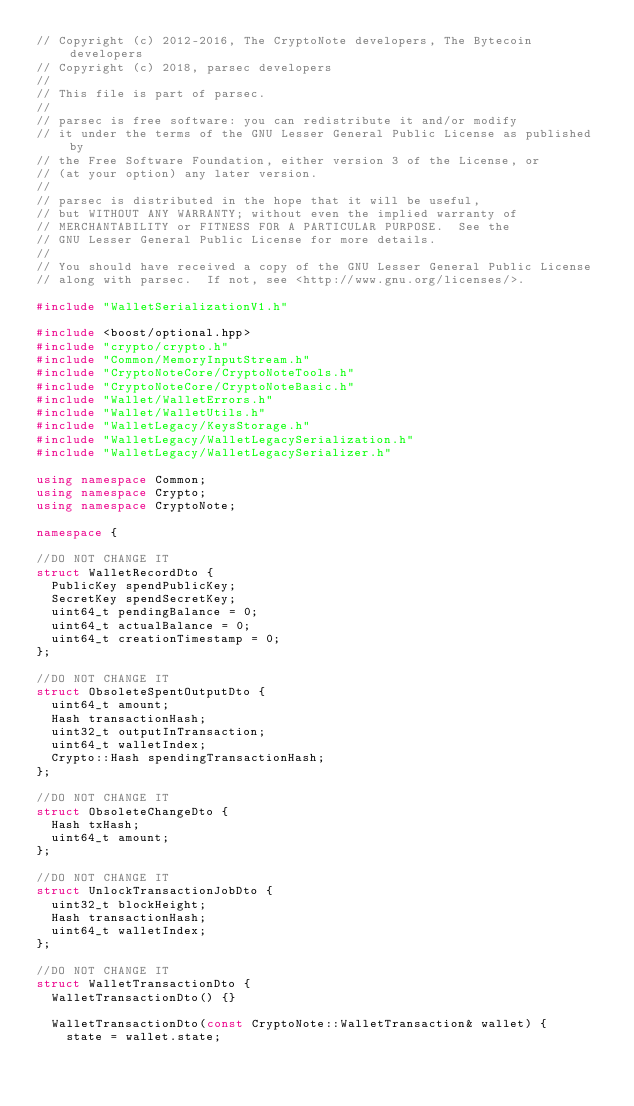Convert code to text. <code><loc_0><loc_0><loc_500><loc_500><_C++_>// Copyright (c) 2012-2016, The CryptoNote developers, The Bytecoin developers
// Copyright (c) 2018, parsec developers
//
// This file is part of parsec.
//
// parsec is free software: you can redistribute it and/or modify
// it under the terms of the GNU Lesser General Public License as published by
// the Free Software Foundation, either version 3 of the License, or
// (at your option) any later version.
//
// parsec is distributed in the hope that it will be useful,
// but WITHOUT ANY WARRANTY; without even the implied warranty of
// MERCHANTABILITY or FITNESS FOR A PARTICULAR PURPOSE.  See the
// GNU Lesser General Public License for more details.
//
// You should have received a copy of the GNU Lesser General Public License
// along with parsec.  If not, see <http://www.gnu.org/licenses/>.

#include "WalletSerializationV1.h"

#include <boost/optional.hpp>
#include "crypto/crypto.h"
#include "Common/MemoryInputStream.h"
#include "CryptoNoteCore/CryptoNoteTools.h"
#include "CryptoNoteCore/CryptoNoteBasic.h"
#include "Wallet/WalletErrors.h"
#include "Wallet/WalletUtils.h"
#include "WalletLegacy/KeysStorage.h"
#include "WalletLegacy/WalletLegacySerialization.h"
#include "WalletLegacy/WalletLegacySerializer.h"

using namespace Common;
using namespace Crypto;
using namespace CryptoNote;

namespace {

//DO NOT CHANGE IT
struct WalletRecordDto {
  PublicKey spendPublicKey;
  SecretKey spendSecretKey;
  uint64_t pendingBalance = 0;
  uint64_t actualBalance = 0;
  uint64_t creationTimestamp = 0;
};

//DO NOT CHANGE IT
struct ObsoleteSpentOutputDto {
  uint64_t amount;
  Hash transactionHash;
  uint32_t outputInTransaction;
  uint64_t walletIndex;
  Crypto::Hash spendingTransactionHash;
};

//DO NOT CHANGE IT
struct ObsoleteChangeDto {
  Hash txHash;
  uint64_t amount;
};

//DO NOT CHANGE IT
struct UnlockTransactionJobDto {
  uint32_t blockHeight;
  Hash transactionHash;
  uint64_t walletIndex;
};

//DO NOT CHANGE IT
struct WalletTransactionDto {
  WalletTransactionDto() {}

  WalletTransactionDto(const CryptoNote::WalletTransaction& wallet) {
    state = wallet.state;</code> 